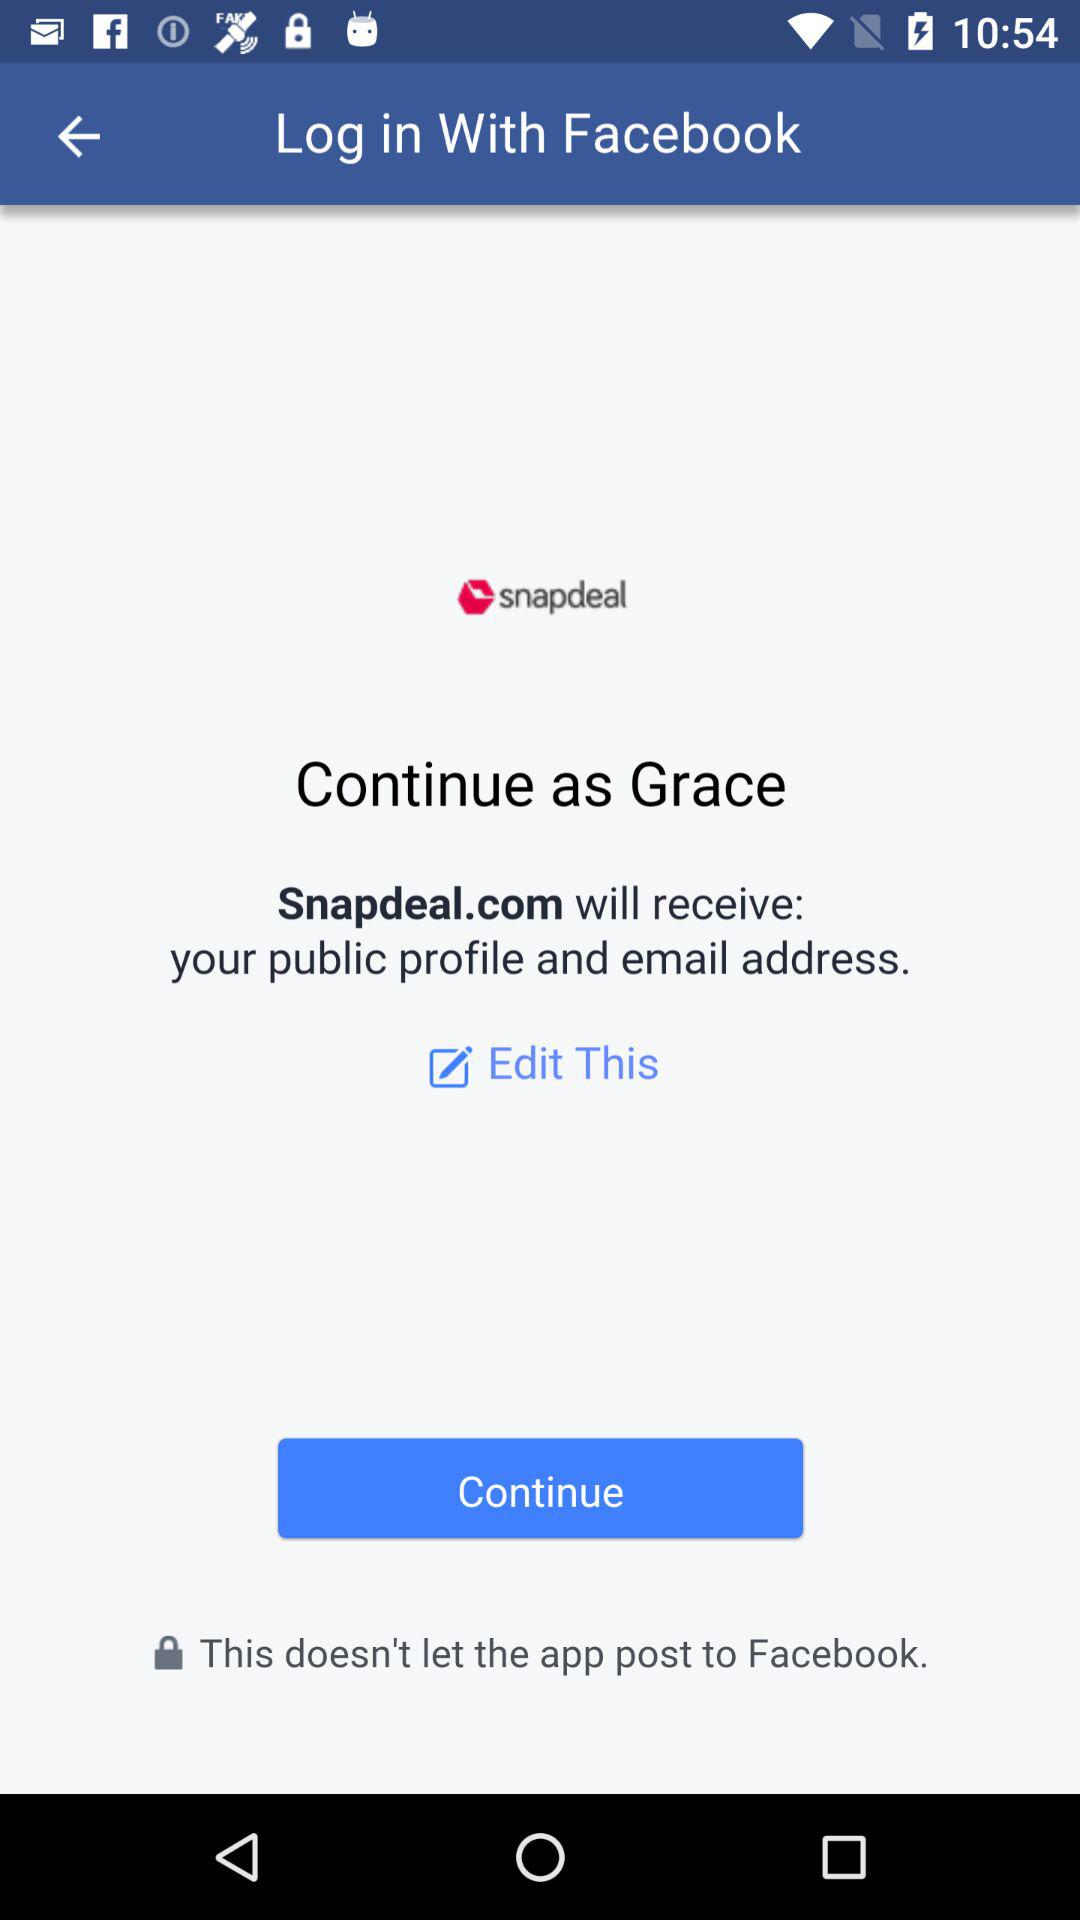What application will receive the public profile and an email address? The application that will receive the public profile and an email address is "Snapdeal.com". 